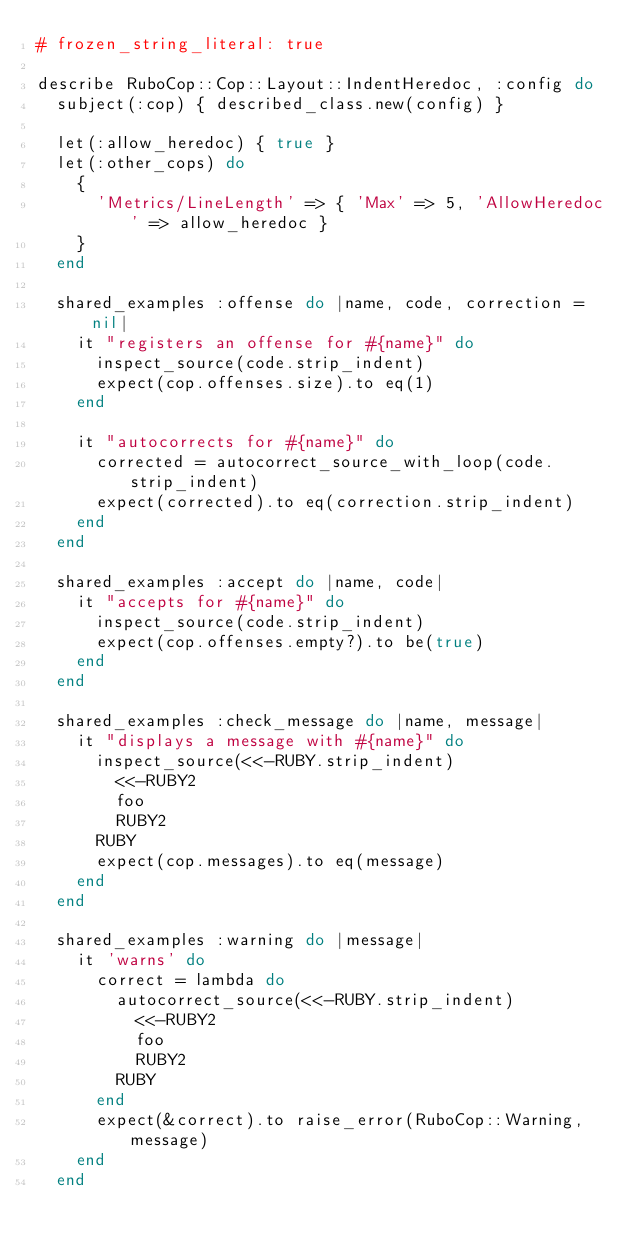Convert code to text. <code><loc_0><loc_0><loc_500><loc_500><_Ruby_># frozen_string_literal: true

describe RuboCop::Cop::Layout::IndentHeredoc, :config do
  subject(:cop) { described_class.new(config) }

  let(:allow_heredoc) { true }
  let(:other_cops) do
    {
      'Metrics/LineLength' => { 'Max' => 5, 'AllowHeredoc' => allow_heredoc }
    }
  end

  shared_examples :offense do |name, code, correction = nil|
    it "registers an offense for #{name}" do
      inspect_source(code.strip_indent)
      expect(cop.offenses.size).to eq(1)
    end

    it "autocorrects for #{name}" do
      corrected = autocorrect_source_with_loop(code.strip_indent)
      expect(corrected).to eq(correction.strip_indent)
    end
  end

  shared_examples :accept do |name, code|
    it "accepts for #{name}" do
      inspect_source(code.strip_indent)
      expect(cop.offenses.empty?).to be(true)
    end
  end

  shared_examples :check_message do |name, message|
    it "displays a message with #{name}" do
      inspect_source(<<-RUBY.strip_indent)
        <<-RUBY2
        foo
        RUBY2
      RUBY
      expect(cop.messages).to eq(message)
    end
  end

  shared_examples :warning do |message|
    it 'warns' do
      correct = lambda do
        autocorrect_source(<<-RUBY.strip_indent)
          <<-RUBY2
          foo
          RUBY2
        RUBY
      end
      expect(&correct).to raise_error(RuboCop::Warning, message)
    end
  end
</code> 